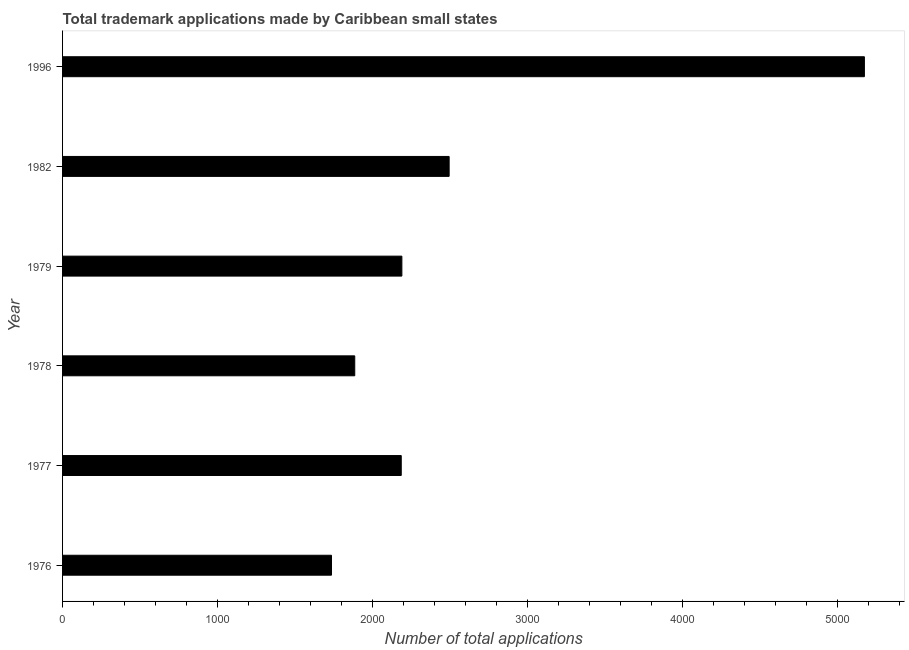Does the graph contain any zero values?
Make the answer very short. No. What is the title of the graph?
Your answer should be compact. Total trademark applications made by Caribbean small states. What is the label or title of the X-axis?
Your answer should be very brief. Number of total applications. What is the label or title of the Y-axis?
Give a very brief answer. Year. What is the number of trademark applications in 1996?
Provide a short and direct response. 5173. Across all years, what is the maximum number of trademark applications?
Your answer should be very brief. 5173. Across all years, what is the minimum number of trademark applications?
Offer a terse response. 1735. In which year was the number of trademark applications maximum?
Your response must be concise. 1996. In which year was the number of trademark applications minimum?
Offer a terse response. 1976. What is the sum of the number of trademark applications?
Give a very brief answer. 1.57e+04. What is the difference between the number of trademark applications in 1976 and 1977?
Give a very brief answer. -450. What is the average number of trademark applications per year?
Provide a short and direct response. 2610. What is the median number of trademark applications?
Provide a succinct answer. 2187. What is the ratio of the number of trademark applications in 1977 to that in 1996?
Make the answer very short. 0.42. Is the difference between the number of trademark applications in 1978 and 1996 greater than the difference between any two years?
Provide a succinct answer. No. What is the difference between the highest and the second highest number of trademark applications?
Your answer should be compact. 2679. What is the difference between the highest and the lowest number of trademark applications?
Ensure brevity in your answer.  3438. How many bars are there?
Provide a short and direct response. 6. Are all the bars in the graph horizontal?
Offer a terse response. Yes. How many years are there in the graph?
Offer a very short reply. 6. What is the difference between two consecutive major ticks on the X-axis?
Make the answer very short. 1000. What is the Number of total applications in 1976?
Make the answer very short. 1735. What is the Number of total applications in 1977?
Your response must be concise. 2185. What is the Number of total applications of 1978?
Provide a short and direct response. 1885. What is the Number of total applications in 1979?
Provide a short and direct response. 2189. What is the Number of total applications of 1982?
Make the answer very short. 2494. What is the Number of total applications in 1996?
Your answer should be compact. 5173. What is the difference between the Number of total applications in 1976 and 1977?
Keep it short and to the point. -450. What is the difference between the Number of total applications in 1976 and 1978?
Offer a very short reply. -150. What is the difference between the Number of total applications in 1976 and 1979?
Make the answer very short. -454. What is the difference between the Number of total applications in 1976 and 1982?
Ensure brevity in your answer.  -759. What is the difference between the Number of total applications in 1976 and 1996?
Your response must be concise. -3438. What is the difference between the Number of total applications in 1977 and 1978?
Ensure brevity in your answer.  300. What is the difference between the Number of total applications in 1977 and 1979?
Your response must be concise. -4. What is the difference between the Number of total applications in 1977 and 1982?
Ensure brevity in your answer.  -309. What is the difference between the Number of total applications in 1977 and 1996?
Your answer should be very brief. -2988. What is the difference between the Number of total applications in 1978 and 1979?
Ensure brevity in your answer.  -304. What is the difference between the Number of total applications in 1978 and 1982?
Your answer should be very brief. -609. What is the difference between the Number of total applications in 1978 and 1996?
Give a very brief answer. -3288. What is the difference between the Number of total applications in 1979 and 1982?
Make the answer very short. -305. What is the difference between the Number of total applications in 1979 and 1996?
Your answer should be compact. -2984. What is the difference between the Number of total applications in 1982 and 1996?
Provide a succinct answer. -2679. What is the ratio of the Number of total applications in 1976 to that in 1977?
Give a very brief answer. 0.79. What is the ratio of the Number of total applications in 1976 to that in 1978?
Provide a succinct answer. 0.92. What is the ratio of the Number of total applications in 1976 to that in 1979?
Keep it short and to the point. 0.79. What is the ratio of the Number of total applications in 1976 to that in 1982?
Give a very brief answer. 0.7. What is the ratio of the Number of total applications in 1976 to that in 1996?
Offer a very short reply. 0.34. What is the ratio of the Number of total applications in 1977 to that in 1978?
Your answer should be compact. 1.16. What is the ratio of the Number of total applications in 1977 to that in 1979?
Offer a terse response. 1. What is the ratio of the Number of total applications in 1977 to that in 1982?
Give a very brief answer. 0.88. What is the ratio of the Number of total applications in 1977 to that in 1996?
Keep it short and to the point. 0.42. What is the ratio of the Number of total applications in 1978 to that in 1979?
Your answer should be very brief. 0.86. What is the ratio of the Number of total applications in 1978 to that in 1982?
Your answer should be compact. 0.76. What is the ratio of the Number of total applications in 1978 to that in 1996?
Your response must be concise. 0.36. What is the ratio of the Number of total applications in 1979 to that in 1982?
Provide a succinct answer. 0.88. What is the ratio of the Number of total applications in 1979 to that in 1996?
Your answer should be compact. 0.42. What is the ratio of the Number of total applications in 1982 to that in 1996?
Your response must be concise. 0.48. 